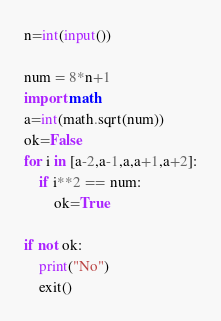<code> <loc_0><loc_0><loc_500><loc_500><_Python_>n=int(input())

num = 8*n+1
import math
a=int(math.sqrt(num))
ok=False
for i in [a-2,a-1,a,a+1,a+2]:
    if i**2 == num:
        ok=True

if not ok:
    print("No")
    exit()</code> 